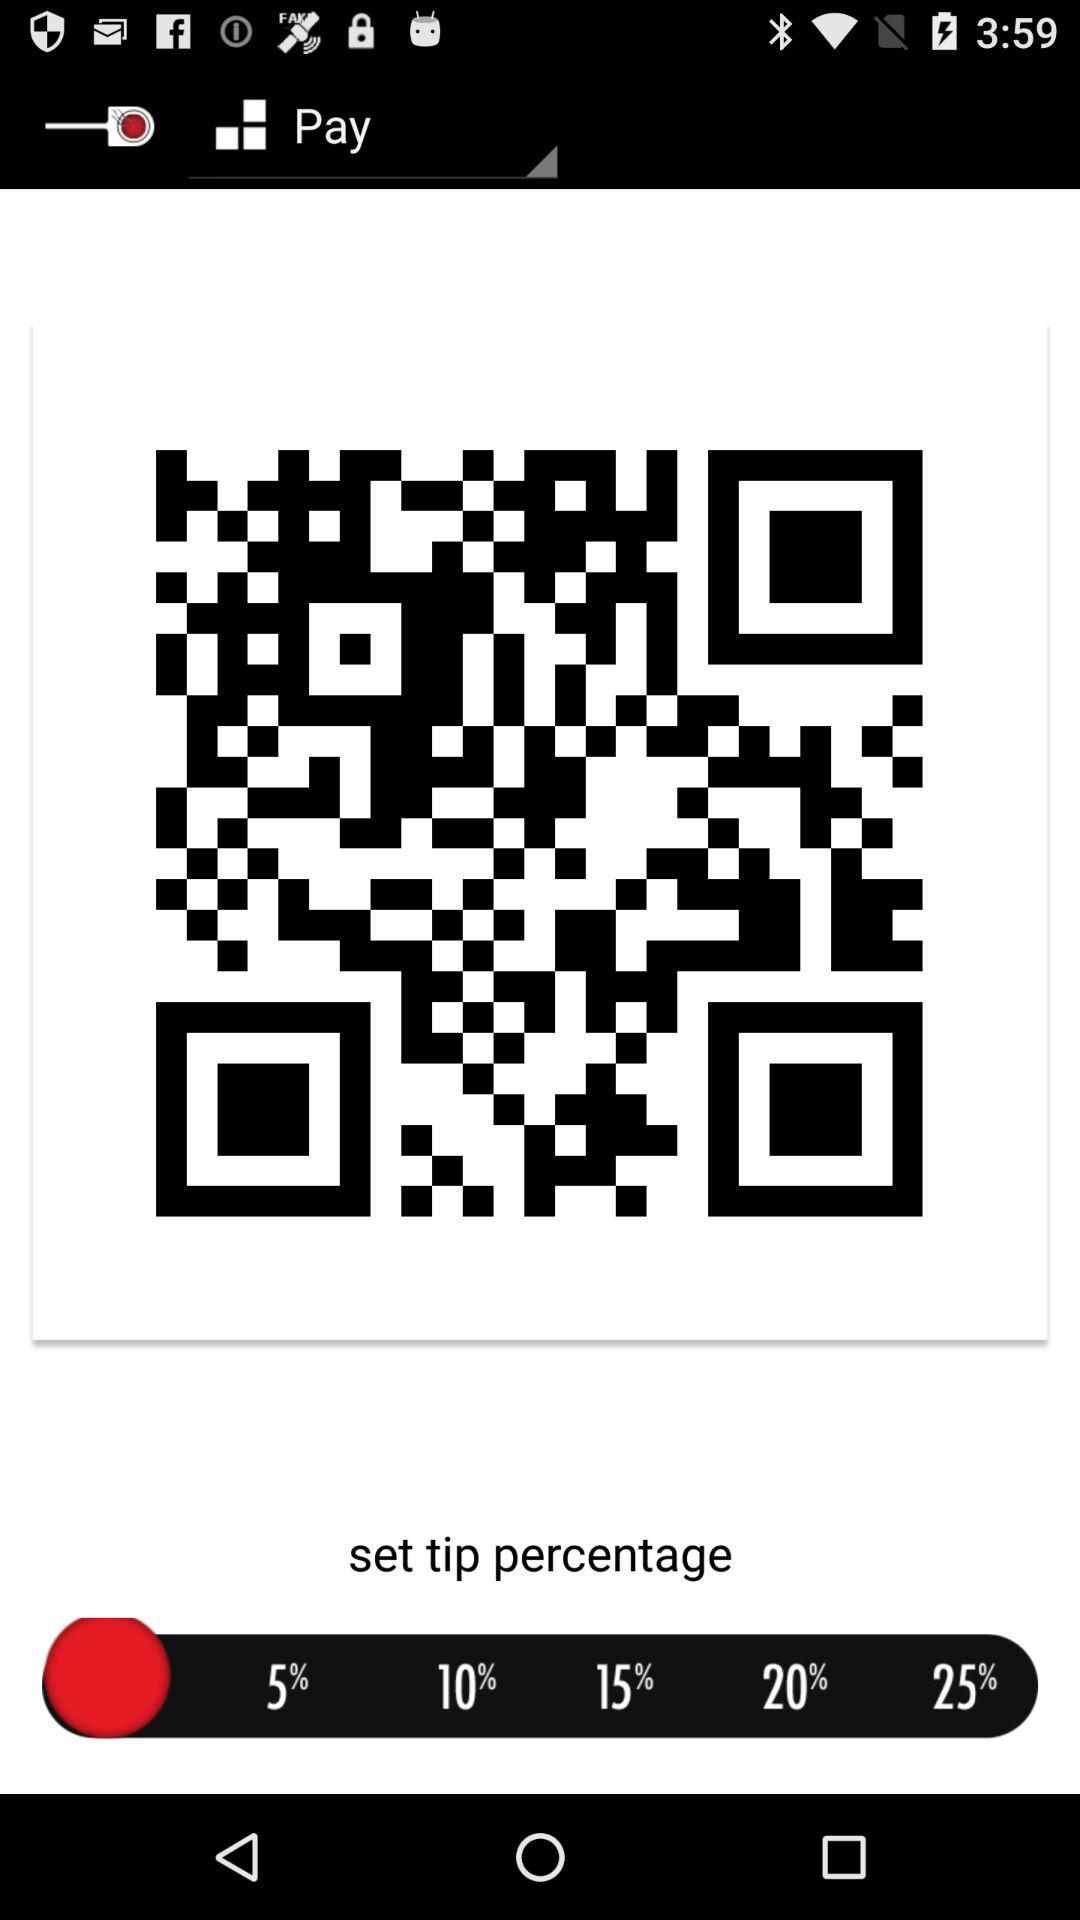What percentage is the tip after adding 5% and 10%?
Answer the question using a single word or phrase. 15% 